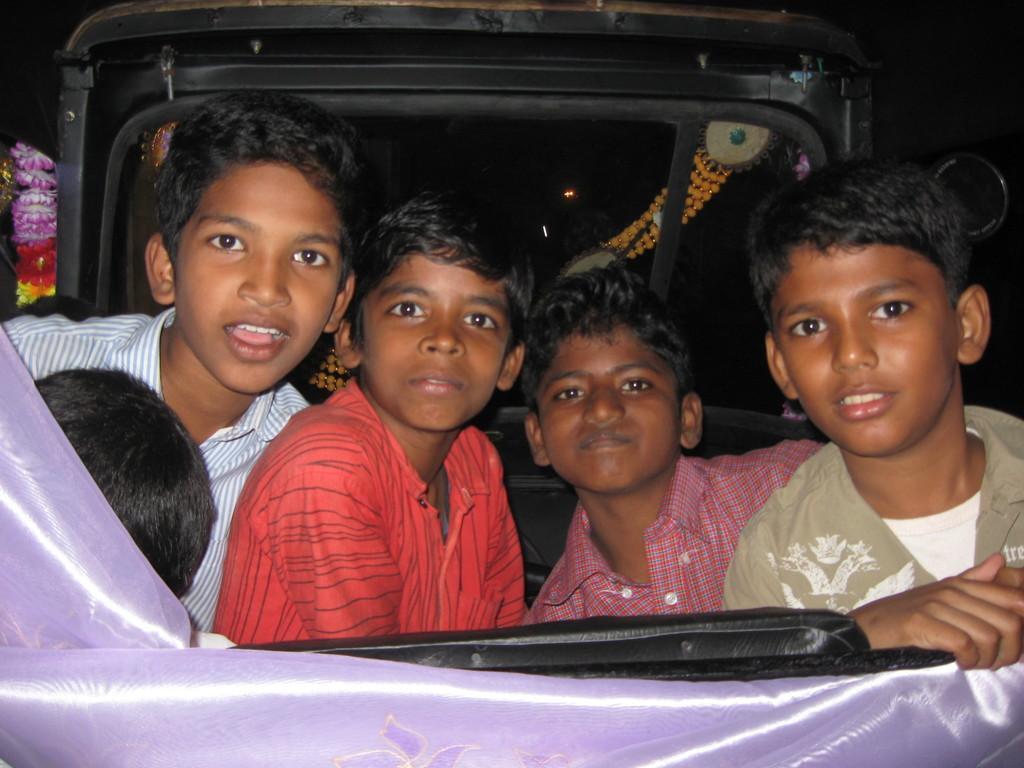Please provide a concise description of this image. In this image, there are a few people. We can see a vehicle with some objects attached to it. We can see some cloth and a black colored object. 